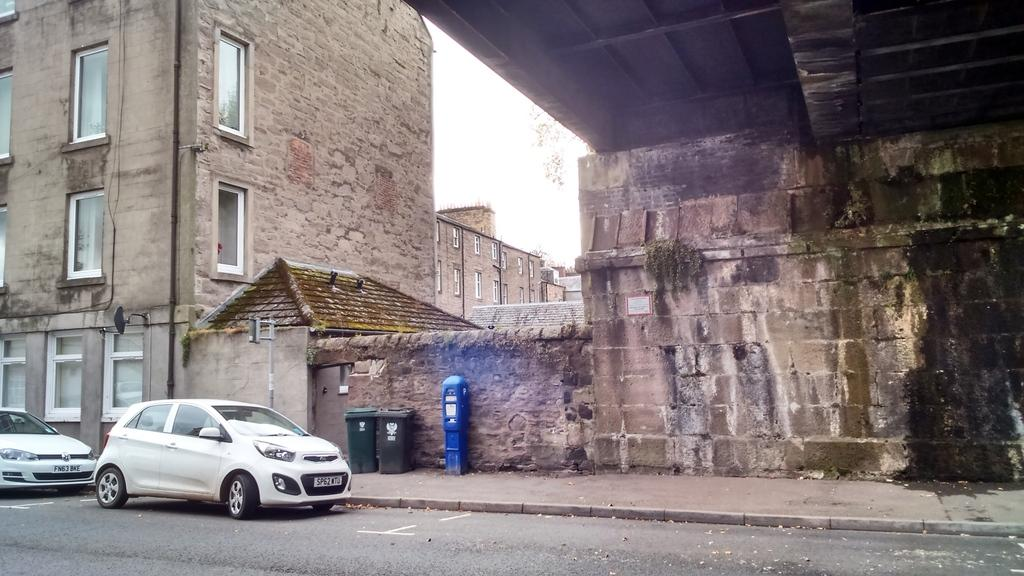What can be seen on the path in the image? There are vehicles and dustbins visible on the path. What else is present on the path? A pole is present on the path. What color is the object visible on the path? There is a blue object visible on the path. What can be seen in the background of the image? There are buildings in the background of the image. What decision is being made by the hands in the image? There are no hands visible in the image, so no decision is being made. What type of base is supporting the vehicles in the image? The vehicles are on a path, and there is no specific base mentioned in the image. 